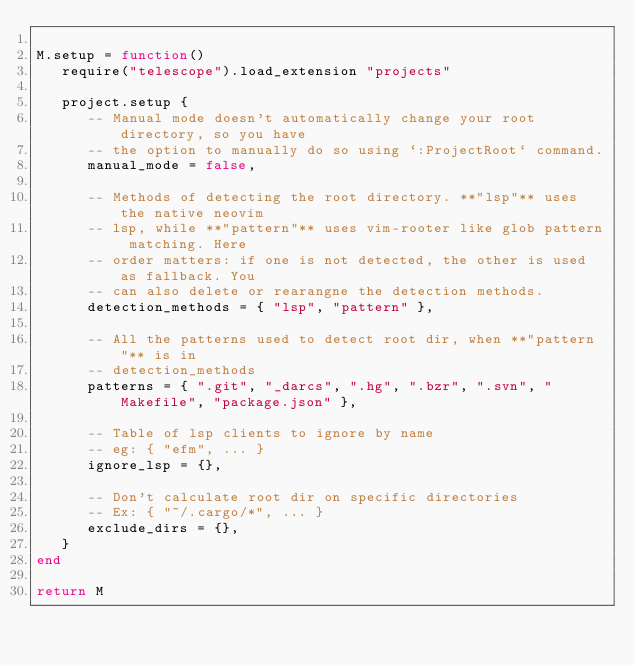<code> <loc_0><loc_0><loc_500><loc_500><_Lua_>
M.setup = function()
   require("telescope").load_extension "projects"

   project.setup {
      -- Manual mode doesn't automatically change your root directory, so you have
      -- the option to manually do so using `:ProjectRoot` command.
      manual_mode = false,

      -- Methods of detecting the root directory. **"lsp"** uses the native neovim
      -- lsp, while **"pattern"** uses vim-rooter like glob pattern matching. Here
      -- order matters: if one is not detected, the other is used as fallback. You
      -- can also delete or rearangne the detection methods.
      detection_methods = { "lsp", "pattern" },

      -- All the patterns used to detect root dir, when **"pattern"** is in
      -- detection_methods
      patterns = { ".git", "_darcs", ".hg", ".bzr", ".svn", "Makefile", "package.json" },

      -- Table of lsp clients to ignore by name
      -- eg: { "efm", ... }
      ignore_lsp = {},

      -- Don't calculate root dir on specific directories
      -- Ex: { "~/.cargo/*", ... }
      exclude_dirs = {},
   }
end

return M
</code> 